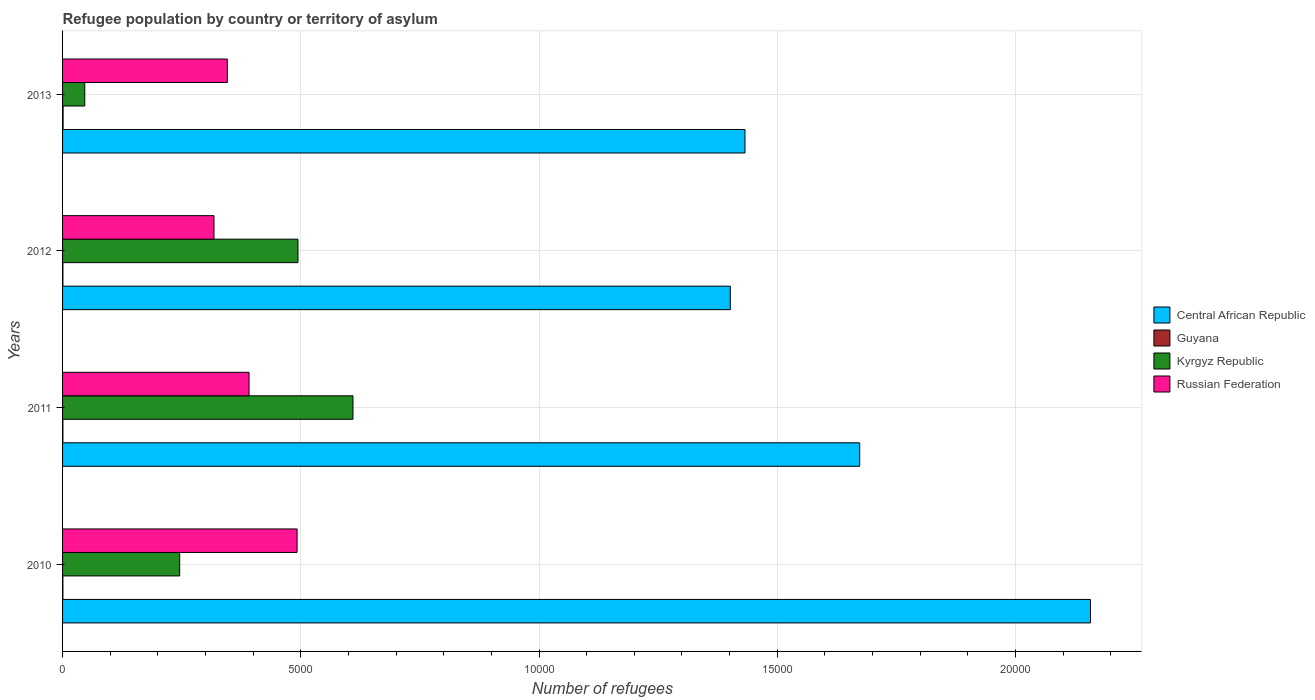How many groups of bars are there?
Give a very brief answer. 4. Are the number of bars per tick equal to the number of legend labels?
Offer a terse response. Yes. How many bars are there on the 3rd tick from the top?
Give a very brief answer. 4. How many bars are there on the 4th tick from the bottom?
Make the answer very short. 4. What is the label of the 3rd group of bars from the top?
Ensure brevity in your answer.  2011. In how many cases, is the number of bars for a given year not equal to the number of legend labels?
Your answer should be very brief. 0. What is the number of refugees in Guyana in 2013?
Make the answer very short. 11. Across all years, what is the maximum number of refugees in Russian Federation?
Your answer should be very brief. 4922. Across all years, what is the minimum number of refugees in Kyrgyz Republic?
Make the answer very short. 466. What is the total number of refugees in Central African Republic in the graph?
Offer a very short reply. 6.66e+04. What is the difference between the number of refugees in Guyana in 2011 and the number of refugees in Russian Federation in 2012?
Provide a short and direct response. -3171. What is the average number of refugees in Central African Republic per year?
Your answer should be very brief. 1.67e+04. In the year 2010, what is the difference between the number of refugees in Guyana and number of refugees in Kyrgyz Republic?
Keep it short and to the point. -2451. In how many years, is the number of refugees in Russian Federation greater than 18000 ?
Offer a terse response. 0. What is the ratio of the number of refugees in Kyrgyz Republic in 2011 to that in 2012?
Keep it short and to the point. 1.23. Is the difference between the number of refugees in Guyana in 2010 and 2012 greater than the difference between the number of refugees in Kyrgyz Republic in 2010 and 2012?
Ensure brevity in your answer.  Yes. What is the difference between the highest and the second highest number of refugees in Central African Republic?
Your answer should be compact. 4844. What is the difference between the highest and the lowest number of refugees in Central African Republic?
Provide a short and direct response. 7560. Is the sum of the number of refugees in Russian Federation in 2010 and 2012 greater than the maximum number of refugees in Kyrgyz Republic across all years?
Offer a very short reply. Yes. What does the 3rd bar from the top in 2012 represents?
Your answer should be compact. Guyana. What does the 3rd bar from the bottom in 2010 represents?
Offer a terse response. Kyrgyz Republic. Are all the bars in the graph horizontal?
Keep it short and to the point. Yes. Are the values on the major ticks of X-axis written in scientific E-notation?
Provide a succinct answer. No. Does the graph contain any zero values?
Ensure brevity in your answer.  No. What is the title of the graph?
Offer a terse response. Refugee population by country or territory of asylum. Does "Lebanon" appear as one of the legend labels in the graph?
Make the answer very short. No. What is the label or title of the X-axis?
Provide a succinct answer. Number of refugees. What is the label or title of the Y-axis?
Make the answer very short. Years. What is the Number of refugees of Central African Republic in 2010?
Provide a short and direct response. 2.16e+04. What is the Number of refugees in Guyana in 2010?
Ensure brevity in your answer.  7. What is the Number of refugees in Kyrgyz Republic in 2010?
Offer a very short reply. 2458. What is the Number of refugees of Russian Federation in 2010?
Ensure brevity in your answer.  4922. What is the Number of refugees in Central African Republic in 2011?
Ensure brevity in your answer.  1.67e+04. What is the Number of refugees of Guyana in 2011?
Your answer should be very brief. 7. What is the Number of refugees in Kyrgyz Republic in 2011?
Keep it short and to the point. 6095. What is the Number of refugees in Russian Federation in 2011?
Offer a very short reply. 3914. What is the Number of refugees of Central African Republic in 2012?
Your answer should be very brief. 1.40e+04. What is the Number of refugees of Guyana in 2012?
Your answer should be very brief. 7. What is the Number of refugees of Kyrgyz Republic in 2012?
Your answer should be very brief. 4941. What is the Number of refugees of Russian Federation in 2012?
Your answer should be compact. 3178. What is the Number of refugees of Central African Republic in 2013?
Make the answer very short. 1.43e+04. What is the Number of refugees of Guyana in 2013?
Offer a terse response. 11. What is the Number of refugees in Kyrgyz Republic in 2013?
Provide a short and direct response. 466. What is the Number of refugees of Russian Federation in 2013?
Your answer should be very brief. 3458. Across all years, what is the maximum Number of refugees in Central African Republic?
Make the answer very short. 2.16e+04. Across all years, what is the maximum Number of refugees of Guyana?
Your answer should be compact. 11. Across all years, what is the maximum Number of refugees of Kyrgyz Republic?
Offer a very short reply. 6095. Across all years, what is the maximum Number of refugees of Russian Federation?
Provide a short and direct response. 4922. Across all years, what is the minimum Number of refugees in Central African Republic?
Provide a short and direct response. 1.40e+04. Across all years, what is the minimum Number of refugees of Guyana?
Offer a terse response. 7. Across all years, what is the minimum Number of refugees in Kyrgyz Republic?
Make the answer very short. 466. Across all years, what is the minimum Number of refugees in Russian Federation?
Your answer should be compact. 3178. What is the total Number of refugees in Central African Republic in the graph?
Ensure brevity in your answer.  6.66e+04. What is the total Number of refugees of Kyrgyz Republic in the graph?
Your answer should be compact. 1.40e+04. What is the total Number of refugees of Russian Federation in the graph?
Provide a short and direct response. 1.55e+04. What is the difference between the Number of refugees in Central African Republic in 2010 and that in 2011?
Make the answer very short. 4844. What is the difference between the Number of refugees of Kyrgyz Republic in 2010 and that in 2011?
Make the answer very short. -3637. What is the difference between the Number of refugees of Russian Federation in 2010 and that in 2011?
Ensure brevity in your answer.  1008. What is the difference between the Number of refugees in Central African Republic in 2010 and that in 2012?
Your answer should be compact. 7560. What is the difference between the Number of refugees in Guyana in 2010 and that in 2012?
Your response must be concise. 0. What is the difference between the Number of refugees of Kyrgyz Republic in 2010 and that in 2012?
Provide a short and direct response. -2483. What is the difference between the Number of refugees in Russian Federation in 2010 and that in 2012?
Offer a terse response. 1744. What is the difference between the Number of refugees of Central African Republic in 2010 and that in 2013?
Give a very brief answer. 7252. What is the difference between the Number of refugees of Kyrgyz Republic in 2010 and that in 2013?
Keep it short and to the point. 1992. What is the difference between the Number of refugees of Russian Federation in 2010 and that in 2013?
Make the answer very short. 1464. What is the difference between the Number of refugees of Central African Republic in 2011 and that in 2012?
Make the answer very short. 2716. What is the difference between the Number of refugees in Kyrgyz Republic in 2011 and that in 2012?
Your answer should be compact. 1154. What is the difference between the Number of refugees of Russian Federation in 2011 and that in 2012?
Keep it short and to the point. 736. What is the difference between the Number of refugees in Central African Republic in 2011 and that in 2013?
Make the answer very short. 2408. What is the difference between the Number of refugees of Guyana in 2011 and that in 2013?
Offer a very short reply. -4. What is the difference between the Number of refugees in Kyrgyz Republic in 2011 and that in 2013?
Keep it short and to the point. 5629. What is the difference between the Number of refugees of Russian Federation in 2011 and that in 2013?
Keep it short and to the point. 456. What is the difference between the Number of refugees in Central African Republic in 2012 and that in 2013?
Ensure brevity in your answer.  -308. What is the difference between the Number of refugees in Guyana in 2012 and that in 2013?
Your response must be concise. -4. What is the difference between the Number of refugees of Kyrgyz Republic in 2012 and that in 2013?
Provide a short and direct response. 4475. What is the difference between the Number of refugees of Russian Federation in 2012 and that in 2013?
Your response must be concise. -280. What is the difference between the Number of refugees in Central African Republic in 2010 and the Number of refugees in Guyana in 2011?
Your answer should be compact. 2.16e+04. What is the difference between the Number of refugees of Central African Republic in 2010 and the Number of refugees of Kyrgyz Republic in 2011?
Provide a short and direct response. 1.55e+04. What is the difference between the Number of refugees of Central African Republic in 2010 and the Number of refugees of Russian Federation in 2011?
Give a very brief answer. 1.77e+04. What is the difference between the Number of refugees in Guyana in 2010 and the Number of refugees in Kyrgyz Republic in 2011?
Keep it short and to the point. -6088. What is the difference between the Number of refugees in Guyana in 2010 and the Number of refugees in Russian Federation in 2011?
Offer a very short reply. -3907. What is the difference between the Number of refugees of Kyrgyz Republic in 2010 and the Number of refugees of Russian Federation in 2011?
Offer a very short reply. -1456. What is the difference between the Number of refugees of Central African Republic in 2010 and the Number of refugees of Guyana in 2012?
Your response must be concise. 2.16e+04. What is the difference between the Number of refugees of Central African Republic in 2010 and the Number of refugees of Kyrgyz Republic in 2012?
Provide a short and direct response. 1.66e+04. What is the difference between the Number of refugees of Central African Republic in 2010 and the Number of refugees of Russian Federation in 2012?
Ensure brevity in your answer.  1.84e+04. What is the difference between the Number of refugees of Guyana in 2010 and the Number of refugees of Kyrgyz Republic in 2012?
Make the answer very short. -4934. What is the difference between the Number of refugees in Guyana in 2010 and the Number of refugees in Russian Federation in 2012?
Give a very brief answer. -3171. What is the difference between the Number of refugees in Kyrgyz Republic in 2010 and the Number of refugees in Russian Federation in 2012?
Ensure brevity in your answer.  -720. What is the difference between the Number of refugees in Central African Republic in 2010 and the Number of refugees in Guyana in 2013?
Your response must be concise. 2.16e+04. What is the difference between the Number of refugees of Central African Republic in 2010 and the Number of refugees of Kyrgyz Republic in 2013?
Ensure brevity in your answer.  2.11e+04. What is the difference between the Number of refugees in Central African Republic in 2010 and the Number of refugees in Russian Federation in 2013?
Ensure brevity in your answer.  1.81e+04. What is the difference between the Number of refugees in Guyana in 2010 and the Number of refugees in Kyrgyz Republic in 2013?
Ensure brevity in your answer.  -459. What is the difference between the Number of refugees in Guyana in 2010 and the Number of refugees in Russian Federation in 2013?
Provide a short and direct response. -3451. What is the difference between the Number of refugees in Kyrgyz Republic in 2010 and the Number of refugees in Russian Federation in 2013?
Keep it short and to the point. -1000. What is the difference between the Number of refugees in Central African Republic in 2011 and the Number of refugees in Guyana in 2012?
Offer a very short reply. 1.67e+04. What is the difference between the Number of refugees of Central African Republic in 2011 and the Number of refugees of Kyrgyz Republic in 2012?
Your answer should be very brief. 1.18e+04. What is the difference between the Number of refugees in Central African Republic in 2011 and the Number of refugees in Russian Federation in 2012?
Provide a short and direct response. 1.36e+04. What is the difference between the Number of refugees in Guyana in 2011 and the Number of refugees in Kyrgyz Republic in 2012?
Ensure brevity in your answer.  -4934. What is the difference between the Number of refugees in Guyana in 2011 and the Number of refugees in Russian Federation in 2012?
Your response must be concise. -3171. What is the difference between the Number of refugees in Kyrgyz Republic in 2011 and the Number of refugees in Russian Federation in 2012?
Your answer should be compact. 2917. What is the difference between the Number of refugees in Central African Republic in 2011 and the Number of refugees in Guyana in 2013?
Provide a succinct answer. 1.67e+04. What is the difference between the Number of refugees of Central African Republic in 2011 and the Number of refugees of Kyrgyz Republic in 2013?
Your answer should be very brief. 1.63e+04. What is the difference between the Number of refugees in Central African Republic in 2011 and the Number of refugees in Russian Federation in 2013?
Your response must be concise. 1.33e+04. What is the difference between the Number of refugees in Guyana in 2011 and the Number of refugees in Kyrgyz Republic in 2013?
Your answer should be very brief. -459. What is the difference between the Number of refugees of Guyana in 2011 and the Number of refugees of Russian Federation in 2013?
Your answer should be compact. -3451. What is the difference between the Number of refugees of Kyrgyz Republic in 2011 and the Number of refugees of Russian Federation in 2013?
Your response must be concise. 2637. What is the difference between the Number of refugees of Central African Republic in 2012 and the Number of refugees of Guyana in 2013?
Your answer should be very brief. 1.40e+04. What is the difference between the Number of refugees in Central African Republic in 2012 and the Number of refugees in Kyrgyz Republic in 2013?
Offer a terse response. 1.35e+04. What is the difference between the Number of refugees in Central African Republic in 2012 and the Number of refugees in Russian Federation in 2013?
Your response must be concise. 1.06e+04. What is the difference between the Number of refugees of Guyana in 2012 and the Number of refugees of Kyrgyz Republic in 2013?
Ensure brevity in your answer.  -459. What is the difference between the Number of refugees of Guyana in 2012 and the Number of refugees of Russian Federation in 2013?
Provide a succinct answer. -3451. What is the difference between the Number of refugees of Kyrgyz Republic in 2012 and the Number of refugees of Russian Federation in 2013?
Offer a very short reply. 1483. What is the average Number of refugees in Central African Republic per year?
Give a very brief answer. 1.67e+04. What is the average Number of refugees of Guyana per year?
Your answer should be compact. 8. What is the average Number of refugees in Kyrgyz Republic per year?
Your answer should be compact. 3490. What is the average Number of refugees of Russian Federation per year?
Offer a terse response. 3868. In the year 2010, what is the difference between the Number of refugees in Central African Republic and Number of refugees in Guyana?
Your answer should be compact. 2.16e+04. In the year 2010, what is the difference between the Number of refugees in Central African Republic and Number of refugees in Kyrgyz Republic?
Offer a very short reply. 1.91e+04. In the year 2010, what is the difference between the Number of refugees of Central African Republic and Number of refugees of Russian Federation?
Keep it short and to the point. 1.67e+04. In the year 2010, what is the difference between the Number of refugees in Guyana and Number of refugees in Kyrgyz Republic?
Provide a short and direct response. -2451. In the year 2010, what is the difference between the Number of refugees of Guyana and Number of refugees of Russian Federation?
Your answer should be compact. -4915. In the year 2010, what is the difference between the Number of refugees of Kyrgyz Republic and Number of refugees of Russian Federation?
Your answer should be compact. -2464. In the year 2011, what is the difference between the Number of refugees of Central African Republic and Number of refugees of Guyana?
Offer a terse response. 1.67e+04. In the year 2011, what is the difference between the Number of refugees in Central African Republic and Number of refugees in Kyrgyz Republic?
Your answer should be compact. 1.06e+04. In the year 2011, what is the difference between the Number of refugees in Central African Republic and Number of refugees in Russian Federation?
Offer a very short reply. 1.28e+04. In the year 2011, what is the difference between the Number of refugees in Guyana and Number of refugees in Kyrgyz Republic?
Offer a very short reply. -6088. In the year 2011, what is the difference between the Number of refugees in Guyana and Number of refugees in Russian Federation?
Provide a short and direct response. -3907. In the year 2011, what is the difference between the Number of refugees of Kyrgyz Republic and Number of refugees of Russian Federation?
Make the answer very short. 2181. In the year 2012, what is the difference between the Number of refugees in Central African Republic and Number of refugees in Guyana?
Your answer should be very brief. 1.40e+04. In the year 2012, what is the difference between the Number of refugees of Central African Republic and Number of refugees of Kyrgyz Republic?
Your response must be concise. 9073. In the year 2012, what is the difference between the Number of refugees in Central African Republic and Number of refugees in Russian Federation?
Offer a very short reply. 1.08e+04. In the year 2012, what is the difference between the Number of refugees of Guyana and Number of refugees of Kyrgyz Republic?
Make the answer very short. -4934. In the year 2012, what is the difference between the Number of refugees of Guyana and Number of refugees of Russian Federation?
Provide a short and direct response. -3171. In the year 2012, what is the difference between the Number of refugees of Kyrgyz Republic and Number of refugees of Russian Federation?
Your answer should be compact. 1763. In the year 2013, what is the difference between the Number of refugees of Central African Republic and Number of refugees of Guyana?
Offer a terse response. 1.43e+04. In the year 2013, what is the difference between the Number of refugees of Central African Republic and Number of refugees of Kyrgyz Republic?
Make the answer very short. 1.39e+04. In the year 2013, what is the difference between the Number of refugees in Central African Republic and Number of refugees in Russian Federation?
Offer a very short reply. 1.09e+04. In the year 2013, what is the difference between the Number of refugees in Guyana and Number of refugees in Kyrgyz Republic?
Offer a terse response. -455. In the year 2013, what is the difference between the Number of refugees in Guyana and Number of refugees in Russian Federation?
Offer a terse response. -3447. In the year 2013, what is the difference between the Number of refugees in Kyrgyz Republic and Number of refugees in Russian Federation?
Ensure brevity in your answer.  -2992. What is the ratio of the Number of refugees of Central African Republic in 2010 to that in 2011?
Offer a terse response. 1.29. What is the ratio of the Number of refugees of Guyana in 2010 to that in 2011?
Your answer should be compact. 1. What is the ratio of the Number of refugees of Kyrgyz Republic in 2010 to that in 2011?
Your answer should be compact. 0.4. What is the ratio of the Number of refugees of Russian Federation in 2010 to that in 2011?
Your response must be concise. 1.26. What is the ratio of the Number of refugees of Central African Republic in 2010 to that in 2012?
Provide a short and direct response. 1.54. What is the ratio of the Number of refugees in Kyrgyz Republic in 2010 to that in 2012?
Make the answer very short. 0.5. What is the ratio of the Number of refugees of Russian Federation in 2010 to that in 2012?
Provide a succinct answer. 1.55. What is the ratio of the Number of refugees in Central African Republic in 2010 to that in 2013?
Offer a terse response. 1.51. What is the ratio of the Number of refugees in Guyana in 2010 to that in 2013?
Provide a short and direct response. 0.64. What is the ratio of the Number of refugees in Kyrgyz Republic in 2010 to that in 2013?
Make the answer very short. 5.27. What is the ratio of the Number of refugees of Russian Federation in 2010 to that in 2013?
Provide a short and direct response. 1.42. What is the ratio of the Number of refugees of Central African Republic in 2011 to that in 2012?
Your answer should be very brief. 1.19. What is the ratio of the Number of refugees in Kyrgyz Republic in 2011 to that in 2012?
Ensure brevity in your answer.  1.23. What is the ratio of the Number of refugees of Russian Federation in 2011 to that in 2012?
Provide a short and direct response. 1.23. What is the ratio of the Number of refugees in Central African Republic in 2011 to that in 2013?
Provide a short and direct response. 1.17. What is the ratio of the Number of refugees in Guyana in 2011 to that in 2013?
Make the answer very short. 0.64. What is the ratio of the Number of refugees of Kyrgyz Republic in 2011 to that in 2013?
Provide a short and direct response. 13.08. What is the ratio of the Number of refugees of Russian Federation in 2011 to that in 2013?
Offer a very short reply. 1.13. What is the ratio of the Number of refugees in Central African Republic in 2012 to that in 2013?
Give a very brief answer. 0.98. What is the ratio of the Number of refugees of Guyana in 2012 to that in 2013?
Ensure brevity in your answer.  0.64. What is the ratio of the Number of refugees of Kyrgyz Republic in 2012 to that in 2013?
Keep it short and to the point. 10.6. What is the ratio of the Number of refugees of Russian Federation in 2012 to that in 2013?
Your answer should be very brief. 0.92. What is the difference between the highest and the second highest Number of refugees in Central African Republic?
Provide a short and direct response. 4844. What is the difference between the highest and the second highest Number of refugees of Guyana?
Make the answer very short. 4. What is the difference between the highest and the second highest Number of refugees in Kyrgyz Republic?
Your answer should be compact. 1154. What is the difference between the highest and the second highest Number of refugees of Russian Federation?
Offer a terse response. 1008. What is the difference between the highest and the lowest Number of refugees in Central African Republic?
Make the answer very short. 7560. What is the difference between the highest and the lowest Number of refugees in Guyana?
Keep it short and to the point. 4. What is the difference between the highest and the lowest Number of refugees of Kyrgyz Republic?
Offer a very short reply. 5629. What is the difference between the highest and the lowest Number of refugees of Russian Federation?
Offer a very short reply. 1744. 